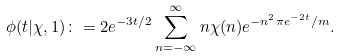Convert formula to latex. <formula><loc_0><loc_0><loc_500><loc_500>\phi ( t | \chi , 1 ) \colon & = 2 e ^ { - 3 t / 2 } \sum _ { n = - \infty } ^ { \infty } n \chi ( n ) e ^ { - n ^ { 2 } \pi e ^ { - 2 t } / m } .</formula> 